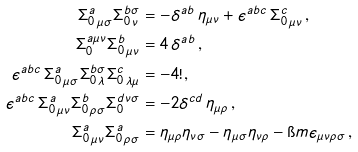<formula> <loc_0><loc_0><loc_500><loc_500>\Sigma ^ { a } _ { 0 \, \mu \sigma } \Sigma ^ { b \sigma } _ { 0 \, \nu } & = - \delta ^ { a b } \, \eta _ { \mu \nu } + \epsilon ^ { a b c } \, \Sigma ^ { c } _ { 0 \, \mu \nu } \, , \\ \Sigma ^ { a \mu \nu } _ { 0 } \Sigma ^ { b } _ { 0 \, \mu \nu } & = 4 \, \delta ^ { a b } \, , \\ \epsilon ^ { a b c } \, \Sigma ^ { a } _ { 0 \, \mu \sigma } \Sigma ^ { b \sigma } _ { 0 \, \lambda } \Sigma ^ { c } _ { 0 \, \lambda \mu } & = - 4 ! \, , \\ \epsilon ^ { a b c } \, \Sigma ^ { a } _ { 0 \, \mu \nu } \Sigma ^ { b } _ { 0 \, \rho \sigma } \Sigma ^ { d \nu \sigma } _ { 0 } & = - 2 \delta ^ { c d } \, \eta _ { \mu \rho } \, , \\ \Sigma ^ { a } _ { 0 \, \mu \nu } \Sigma ^ { a } _ { 0 \, \rho \sigma } & = \eta _ { \mu \rho } \eta _ { \nu \sigma } - \eta _ { \mu \sigma } \eta _ { \nu \rho } - \i m \epsilon _ { \mu \nu \rho \sigma } \, ,</formula> 